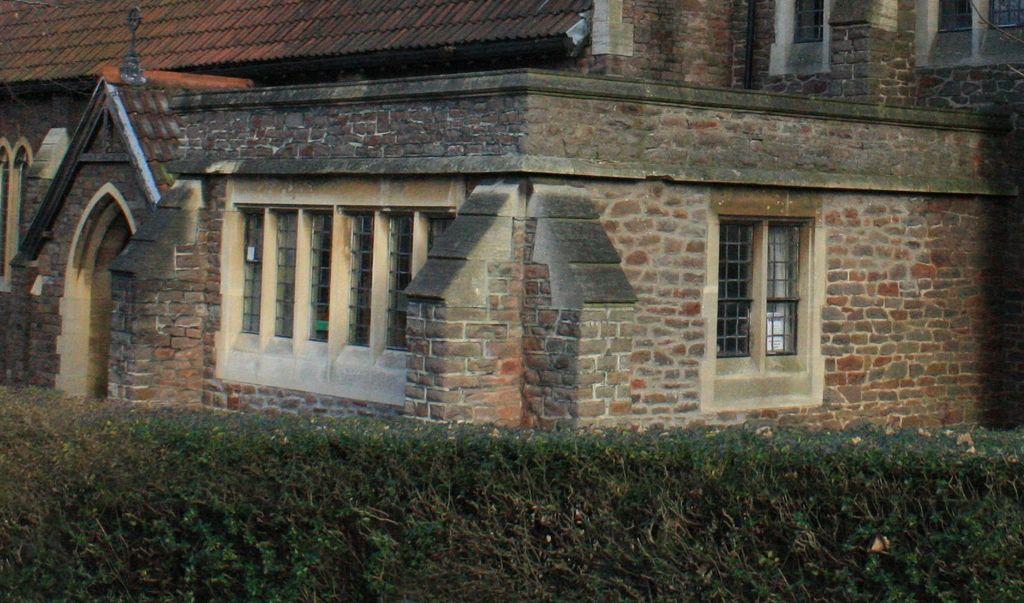How would you summarize this image in a sentence or two? In this image there is a building and we can see a door and windows. At the bottom there is a hedge. 